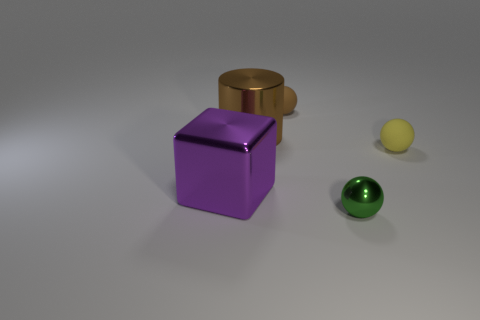There is a brown cylinder that is the same material as the big cube; what is its size?
Keep it short and to the point. Large. How big is the purple object?
Your response must be concise. Large. Is the material of the large brown cylinder the same as the large purple object?
Provide a succinct answer. Yes. What number of cylinders are either large gray shiny things or small objects?
Your answer should be compact. 0. The matte ball that is right of the tiny brown ball that is to the right of the big brown object is what color?
Make the answer very short. Yellow. What is the size of the object that is the same color as the cylinder?
Offer a terse response. Small. There is a brown object left of the object that is behind the big brown metal object; what number of green objects are on the left side of it?
Provide a short and direct response. 0. There is a small rubber object that is to the left of the metal sphere; is it the same shape as the tiny rubber thing that is in front of the tiny brown matte ball?
Ensure brevity in your answer.  Yes. How many objects are large metal cylinders or green shiny balls?
Give a very brief answer. 2. What is the material of the sphere behind the tiny matte sphere that is on the right side of the green metallic object?
Give a very brief answer. Rubber. 